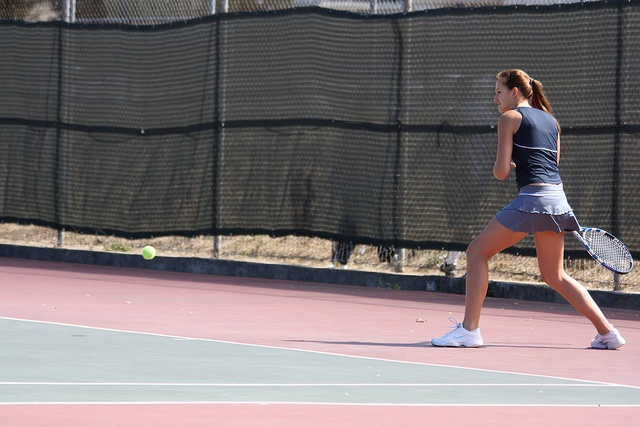Describe the objects in this image and their specific colors. I can see people in black, gray, brown, and lavender tones, tennis racket in black, darkgray, lightgray, and gray tones, people in black, gray, and darkgray tones, and sports ball in black, lightgreen, khaki, beige, and olive tones in this image. 